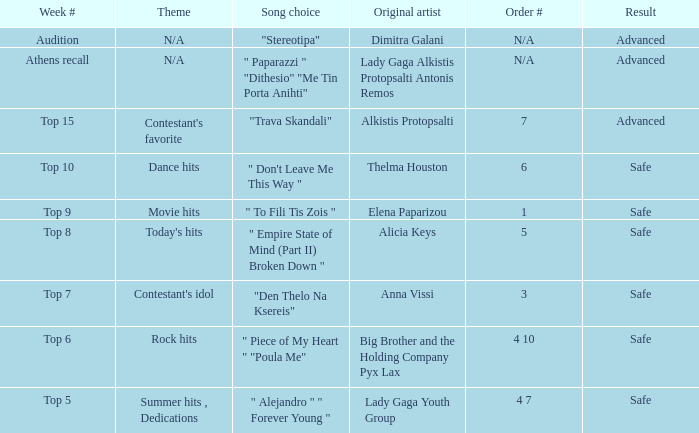Which song was chosen during the audition week? "Stereotipa". 